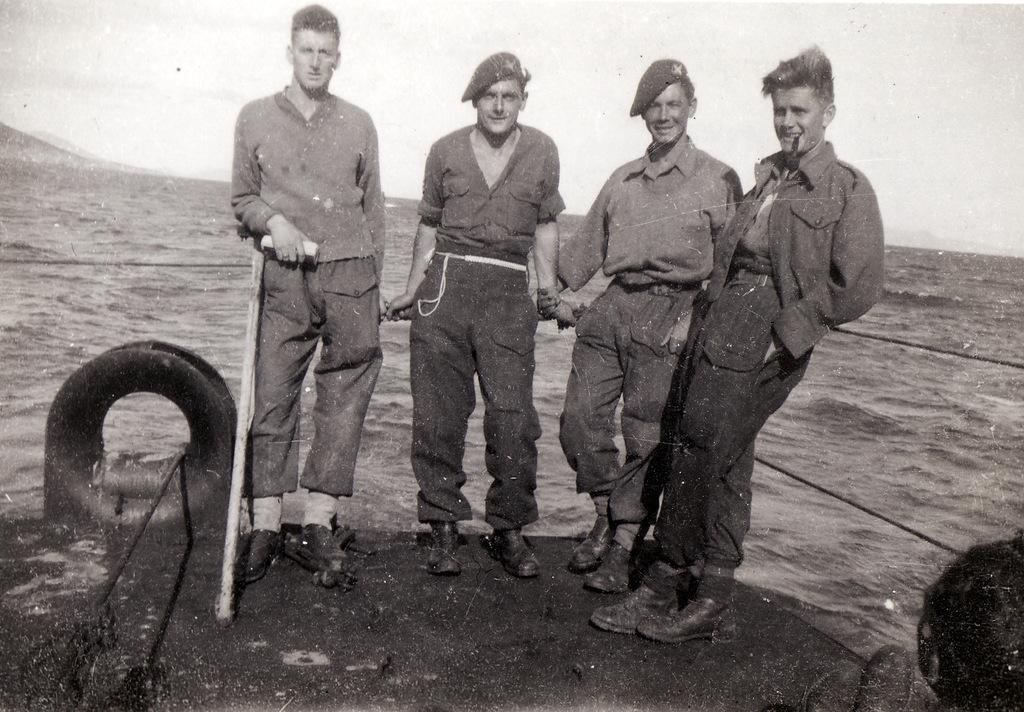Could you give a brief overview of what you see in this image? In this image, we can see four people are standing and smiling. Here we can see ropes,stick, tyre. Background we can see the sea. 